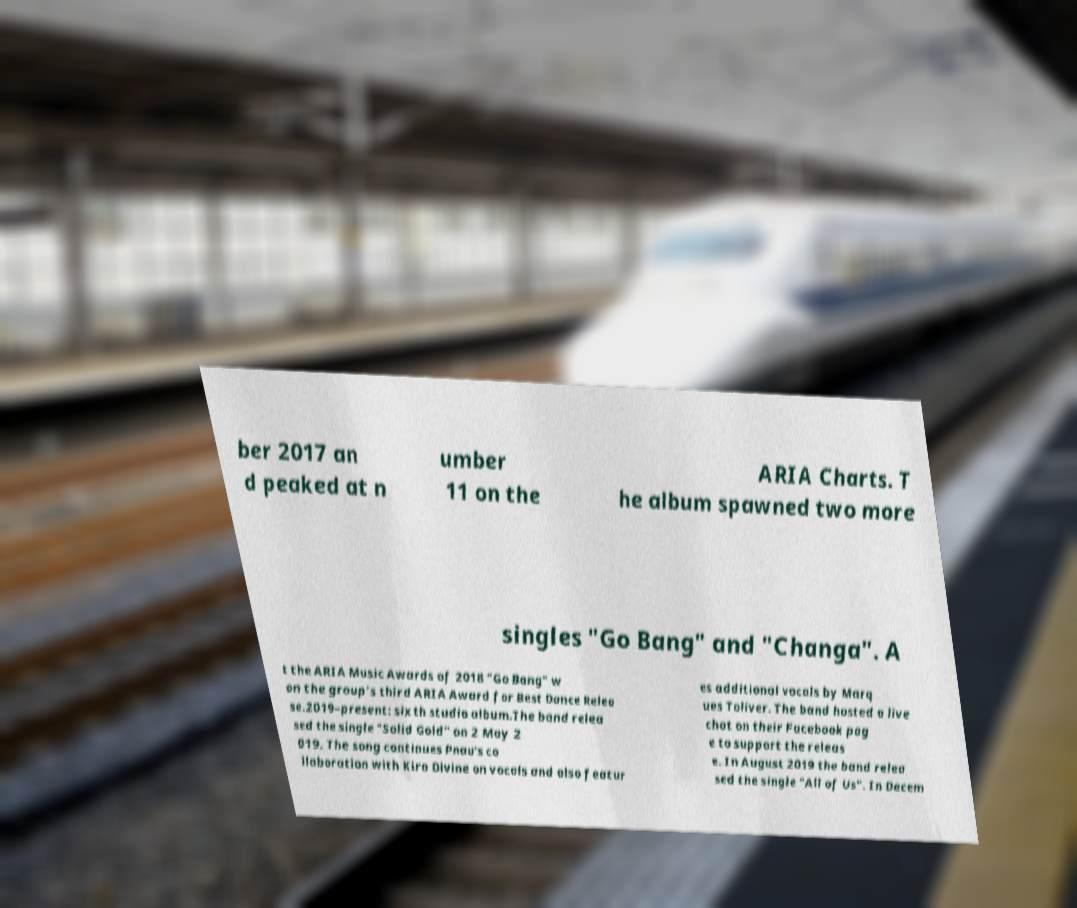Can you accurately transcribe the text from the provided image for me? ber 2017 an d peaked at n umber 11 on the ARIA Charts. T he album spawned two more singles "Go Bang" and "Changa". A t the ARIA Music Awards of 2018 "Go Bang" w on the group's third ARIA Award for Best Dance Relea se.2019–present: sixth studio album.The band relea sed the single "Solid Gold" on 2 May 2 019. The song continues Pnau's co llaboration with Kira Divine on vocals and also featur es additional vocals by Marq ues Toliver. The band hosted a live chat on their Facebook pag e to support the releas e. In August 2019 the band relea sed the single "All of Us". In Decem 